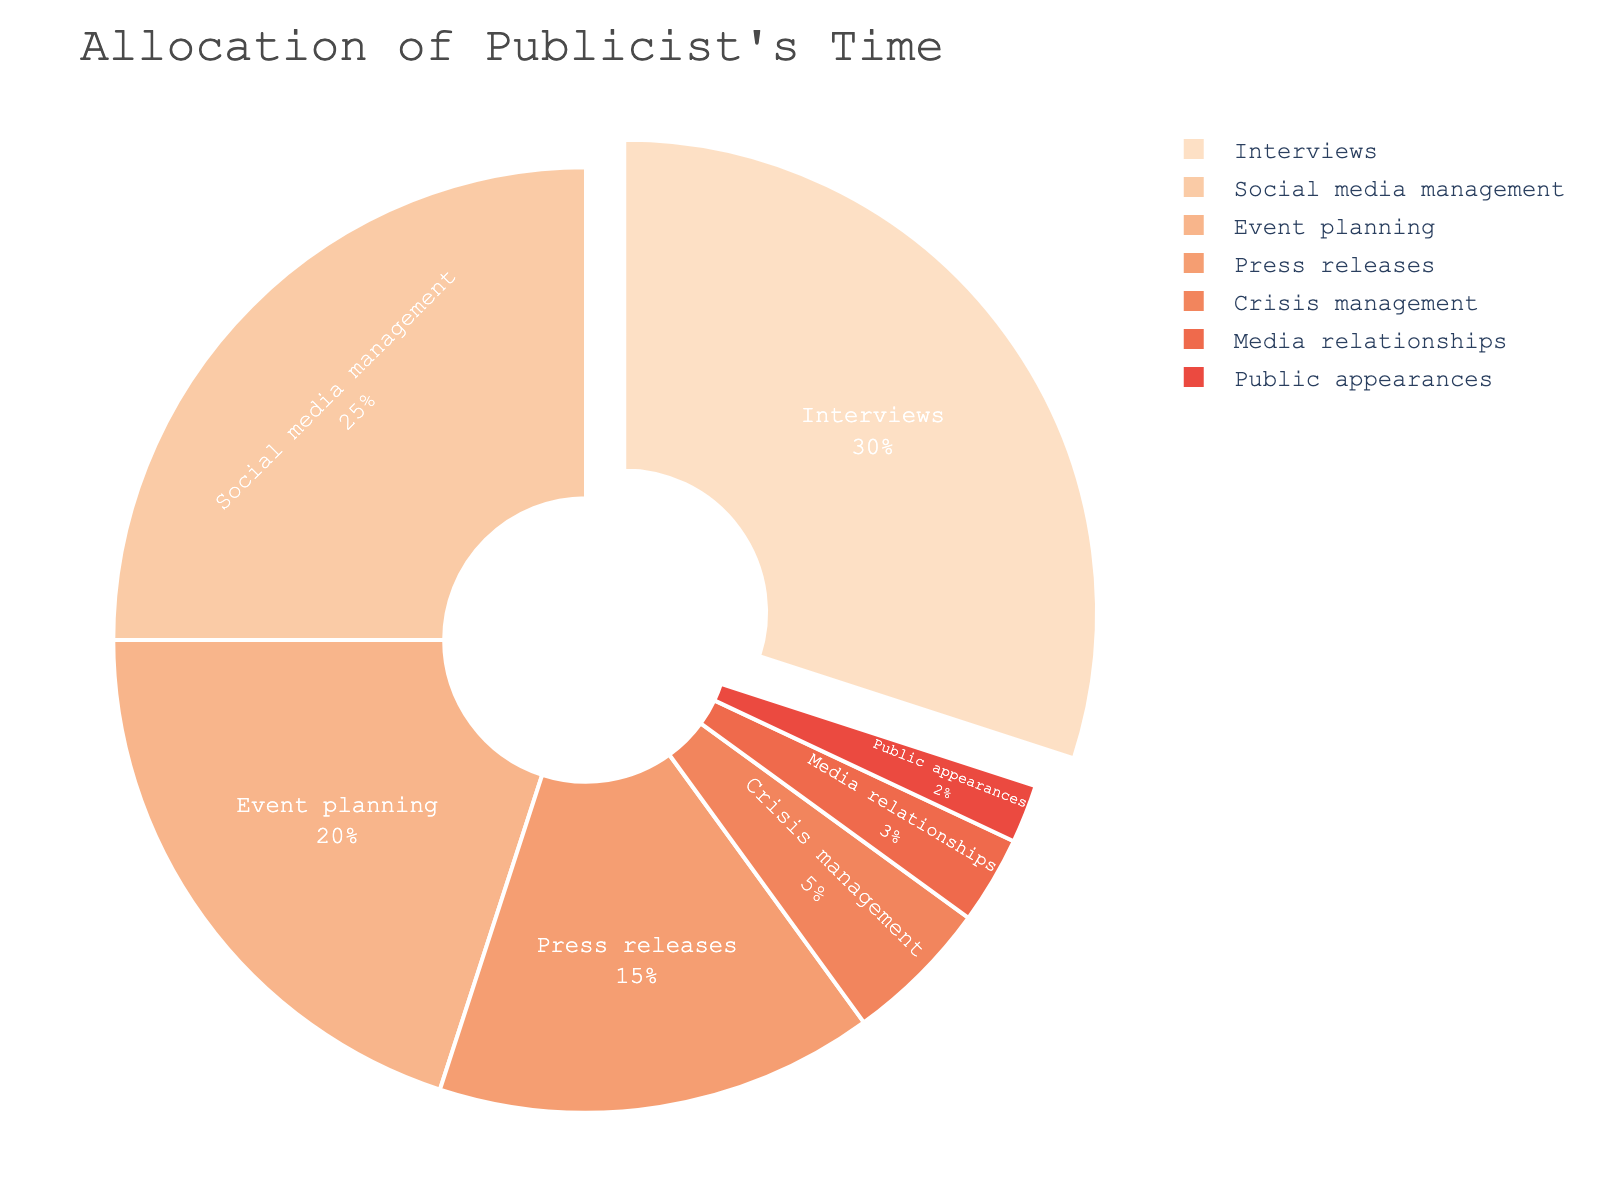Which activity takes up the largest portion of the publicist's time? The activity taking the largest portion of the publicist's time is the one with the highest percentage in the pie chart. From the figure, this is 'Interviews' with 30%.
Answer: Interviews What is the combined percentage for event planning and social media management? To find the combined percentage, add the percentages of 'Event planning' and 'Social media management'. This is 20% + 25% = 45%.
Answer: 45% How does the time spent on interviews compare to press releases? To compare, look at the percentages for 'Interviews' and 'Press releases'. Interviews take 30%, and Press releases take 15%. Since 30% is greater than 15%, more time is spent on interviews.
Answer: More time is spent on interviews Which activities take less than 10% of the publicist's time? Look for activities with percentages less than 10% in the figure. These activities are 'Crisis management' (5%), 'Media relationships' (3%), and 'Public appearances' (2%).
Answer: Crisis management, Media relationships, Public appearances What is the smallest slice of the pie chart, and what does it represent? The smallest slice of the pie chart represents the activity with the lowest percentage. From the figure, this is 'Public appearances' with 2%.
Answer: Public appearances How much more time is allocated to social media management compared to crisis management? Subtract the percentage for 'Crisis management' from 'Social media management'. This is 25% - 5% = 20%.
Answer: 20% Which two activities combined take nearly half of the publicist's time? Sum the percentages for the activities until you reach close to 50%. 'Interviews' (30%) and 'Social media management' (25%) sum to 55%, which is the closest.
Answer: Interviews and Social media management Are the time allocations for media relationships and public appearances similar? Compare the percentages for 'Media relationships' and 'Public appearances'. Media relationships take 3% and Public appearances take 2%. They are close but not the same.
Answer: Yes, they are similar Which activity takes five times more time than public appearances? Identify the percentage for 'Public appearances' (2%) and find an activity that is five times this amount, which is 2% * 5 = 10%. 'Crisis management' at 5% fits, but 'Press releases' at 15% is exactly three times, not five times. No exact match, but 'Press releases' is closer to multiple times larger.
Answer: Press releases, although not exactly five times 